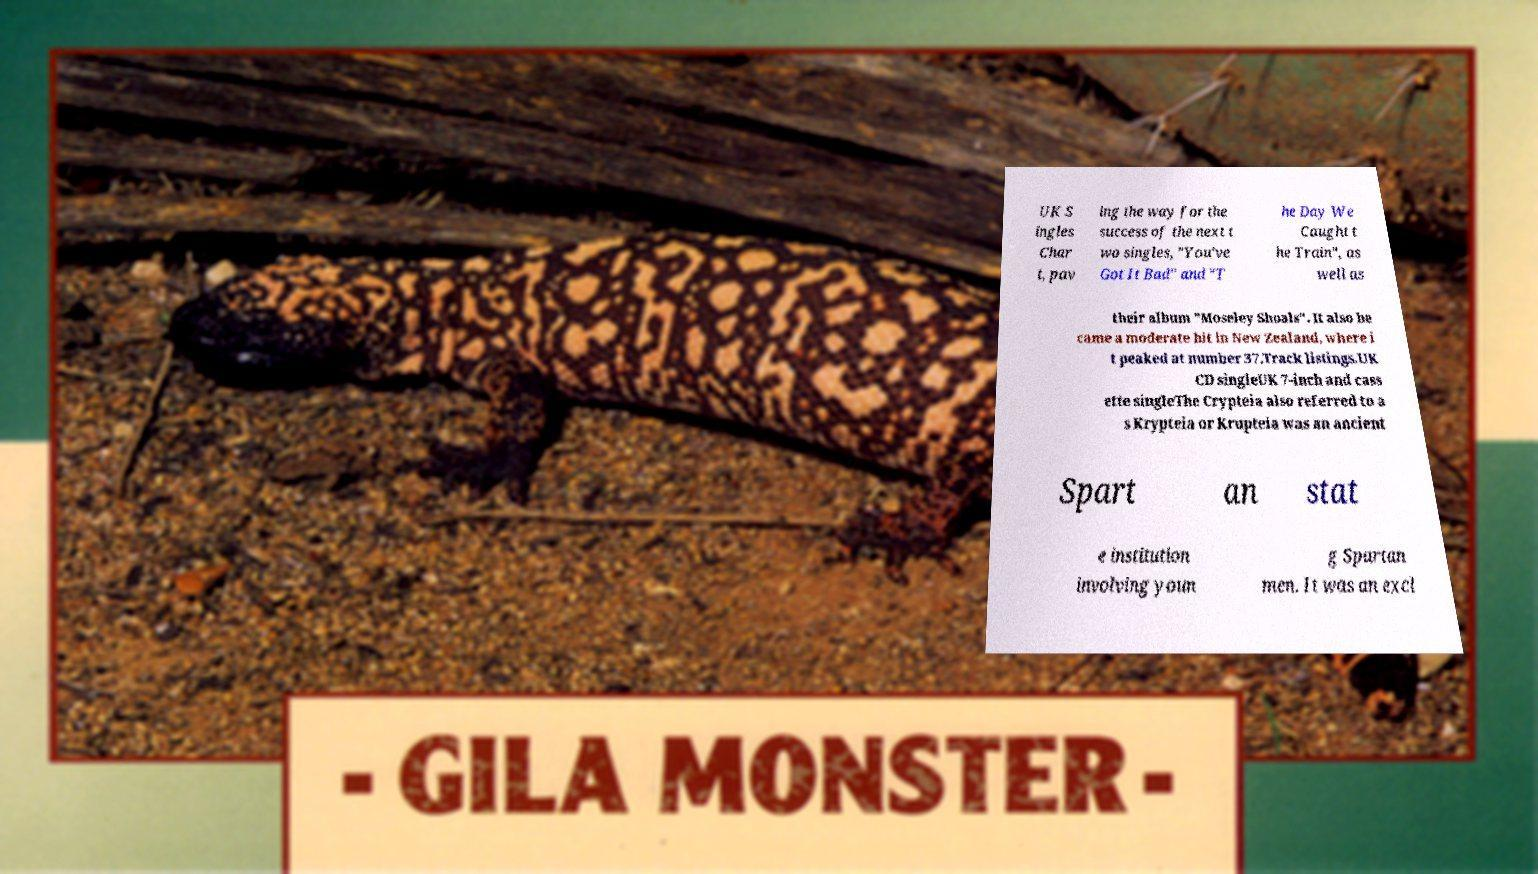I need the written content from this picture converted into text. Can you do that? UK S ingles Char t, pav ing the way for the success of the next t wo singles, "You've Got It Bad" and "T he Day We Caught t he Train", as well as their album "Moseley Shoals". It also be came a moderate hit in New Zealand, where i t peaked at number 37.Track listings.UK CD singleUK 7-inch and cass ette singleThe Crypteia also referred to a s Krypteia or Krupteia was an ancient Spart an stat e institution involving youn g Spartan men. It was an excl 